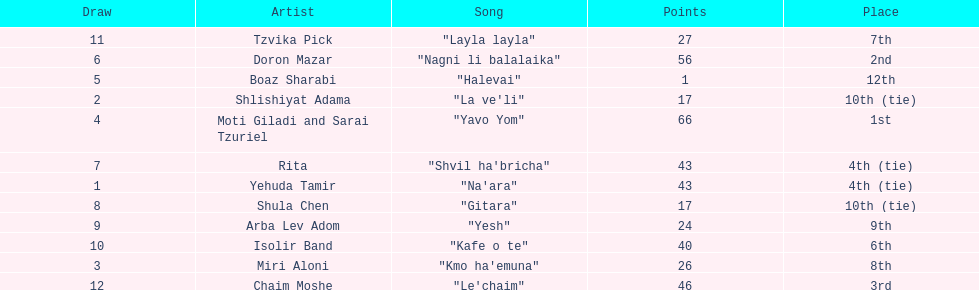What is the total amount of ties in this competition? 2. 